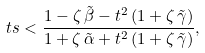Convert formula to latex. <formula><loc_0><loc_0><loc_500><loc_500>\ t s < \frac { 1 - \zeta \, \tilde { \beta } - t ^ { 2 } \, ( 1 + \zeta \, \tilde { \gamma } ) } { 1 + \zeta \, \tilde { \alpha } + t ^ { 2 } \, ( 1 + \zeta \, \tilde { \gamma } ) } ,</formula> 